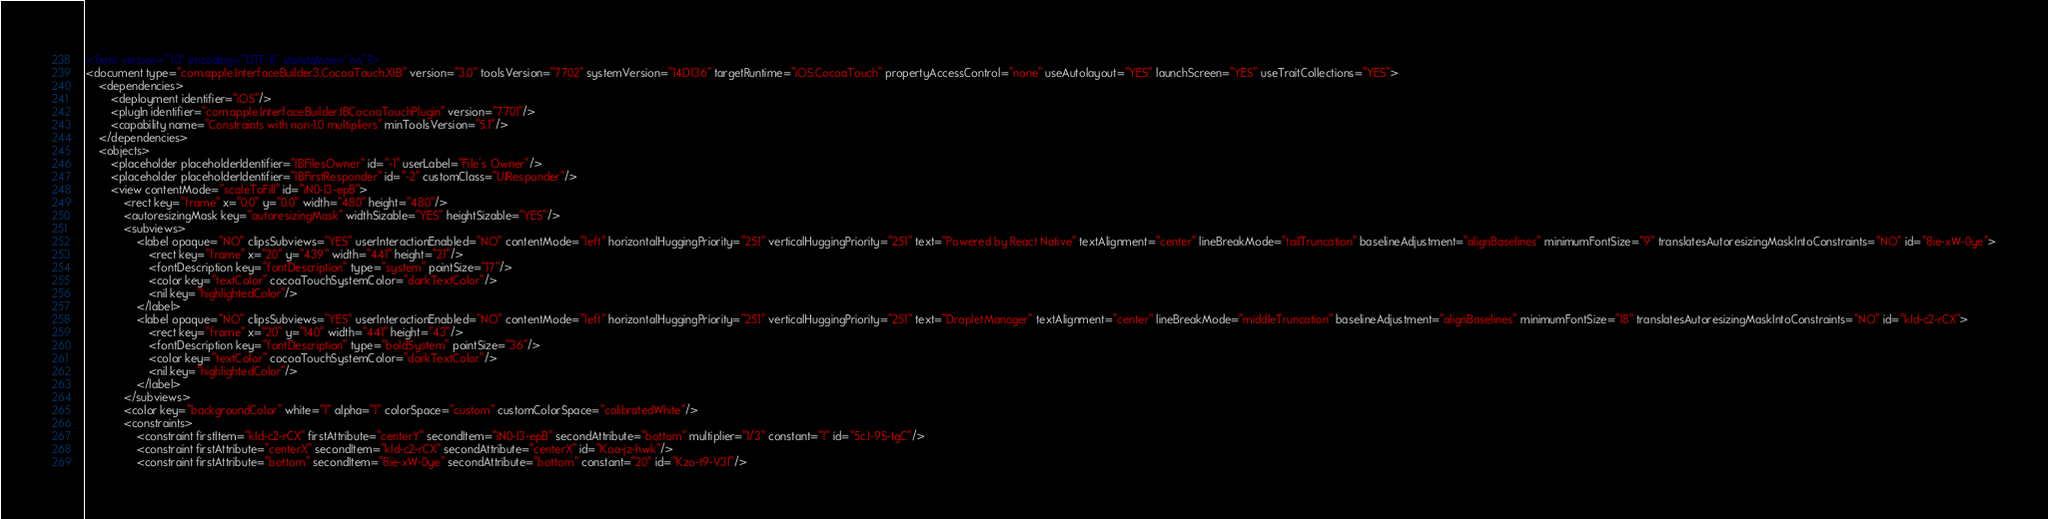<code> <loc_0><loc_0><loc_500><loc_500><_XML_><?xml version="1.0" encoding="UTF-8" standalone="no"?>
<document type="com.apple.InterfaceBuilder3.CocoaTouch.XIB" version="3.0" toolsVersion="7702" systemVersion="14D136" targetRuntime="iOS.CocoaTouch" propertyAccessControl="none" useAutolayout="YES" launchScreen="YES" useTraitCollections="YES">
    <dependencies>
        <deployment identifier="iOS"/>
        <plugIn identifier="com.apple.InterfaceBuilder.IBCocoaTouchPlugin" version="7701"/>
        <capability name="Constraints with non-1.0 multipliers" minToolsVersion="5.1"/>
    </dependencies>
    <objects>
        <placeholder placeholderIdentifier="IBFilesOwner" id="-1" userLabel="File's Owner"/>
        <placeholder placeholderIdentifier="IBFirstResponder" id="-2" customClass="UIResponder"/>
        <view contentMode="scaleToFill" id="iN0-l3-epB">
            <rect key="frame" x="0.0" y="0.0" width="480" height="480"/>
            <autoresizingMask key="autoresizingMask" widthSizable="YES" heightSizable="YES"/>
            <subviews>
                <label opaque="NO" clipsSubviews="YES" userInteractionEnabled="NO" contentMode="left" horizontalHuggingPriority="251" verticalHuggingPriority="251" text="Powered by React Native" textAlignment="center" lineBreakMode="tailTruncation" baselineAdjustment="alignBaselines" minimumFontSize="9" translatesAutoresizingMaskIntoConstraints="NO" id="8ie-xW-0ye">
                    <rect key="frame" x="20" y="439" width="441" height="21"/>
                    <fontDescription key="fontDescription" type="system" pointSize="17"/>
                    <color key="textColor" cocoaTouchSystemColor="darkTextColor"/>
                    <nil key="highlightedColor"/>
                </label>
                <label opaque="NO" clipsSubviews="YES" userInteractionEnabled="NO" contentMode="left" horizontalHuggingPriority="251" verticalHuggingPriority="251" text="DropletManager" textAlignment="center" lineBreakMode="middleTruncation" baselineAdjustment="alignBaselines" minimumFontSize="18" translatesAutoresizingMaskIntoConstraints="NO" id="kId-c2-rCX">
                    <rect key="frame" x="20" y="140" width="441" height="43"/>
                    <fontDescription key="fontDescription" type="boldSystem" pointSize="36"/>
                    <color key="textColor" cocoaTouchSystemColor="darkTextColor"/>
                    <nil key="highlightedColor"/>
                </label>
            </subviews>
            <color key="backgroundColor" white="1" alpha="1" colorSpace="custom" customColorSpace="calibratedWhite"/>
            <constraints>
                <constraint firstItem="kId-c2-rCX" firstAttribute="centerY" secondItem="iN0-l3-epB" secondAttribute="bottom" multiplier="1/3" constant="1" id="5cJ-9S-tgC"/>
                <constraint firstAttribute="centerX" secondItem="kId-c2-rCX" secondAttribute="centerX" id="Koa-jz-hwk"/>
                <constraint firstAttribute="bottom" secondItem="8ie-xW-0ye" secondAttribute="bottom" constant="20" id="Kzo-t9-V3l"/></code> 